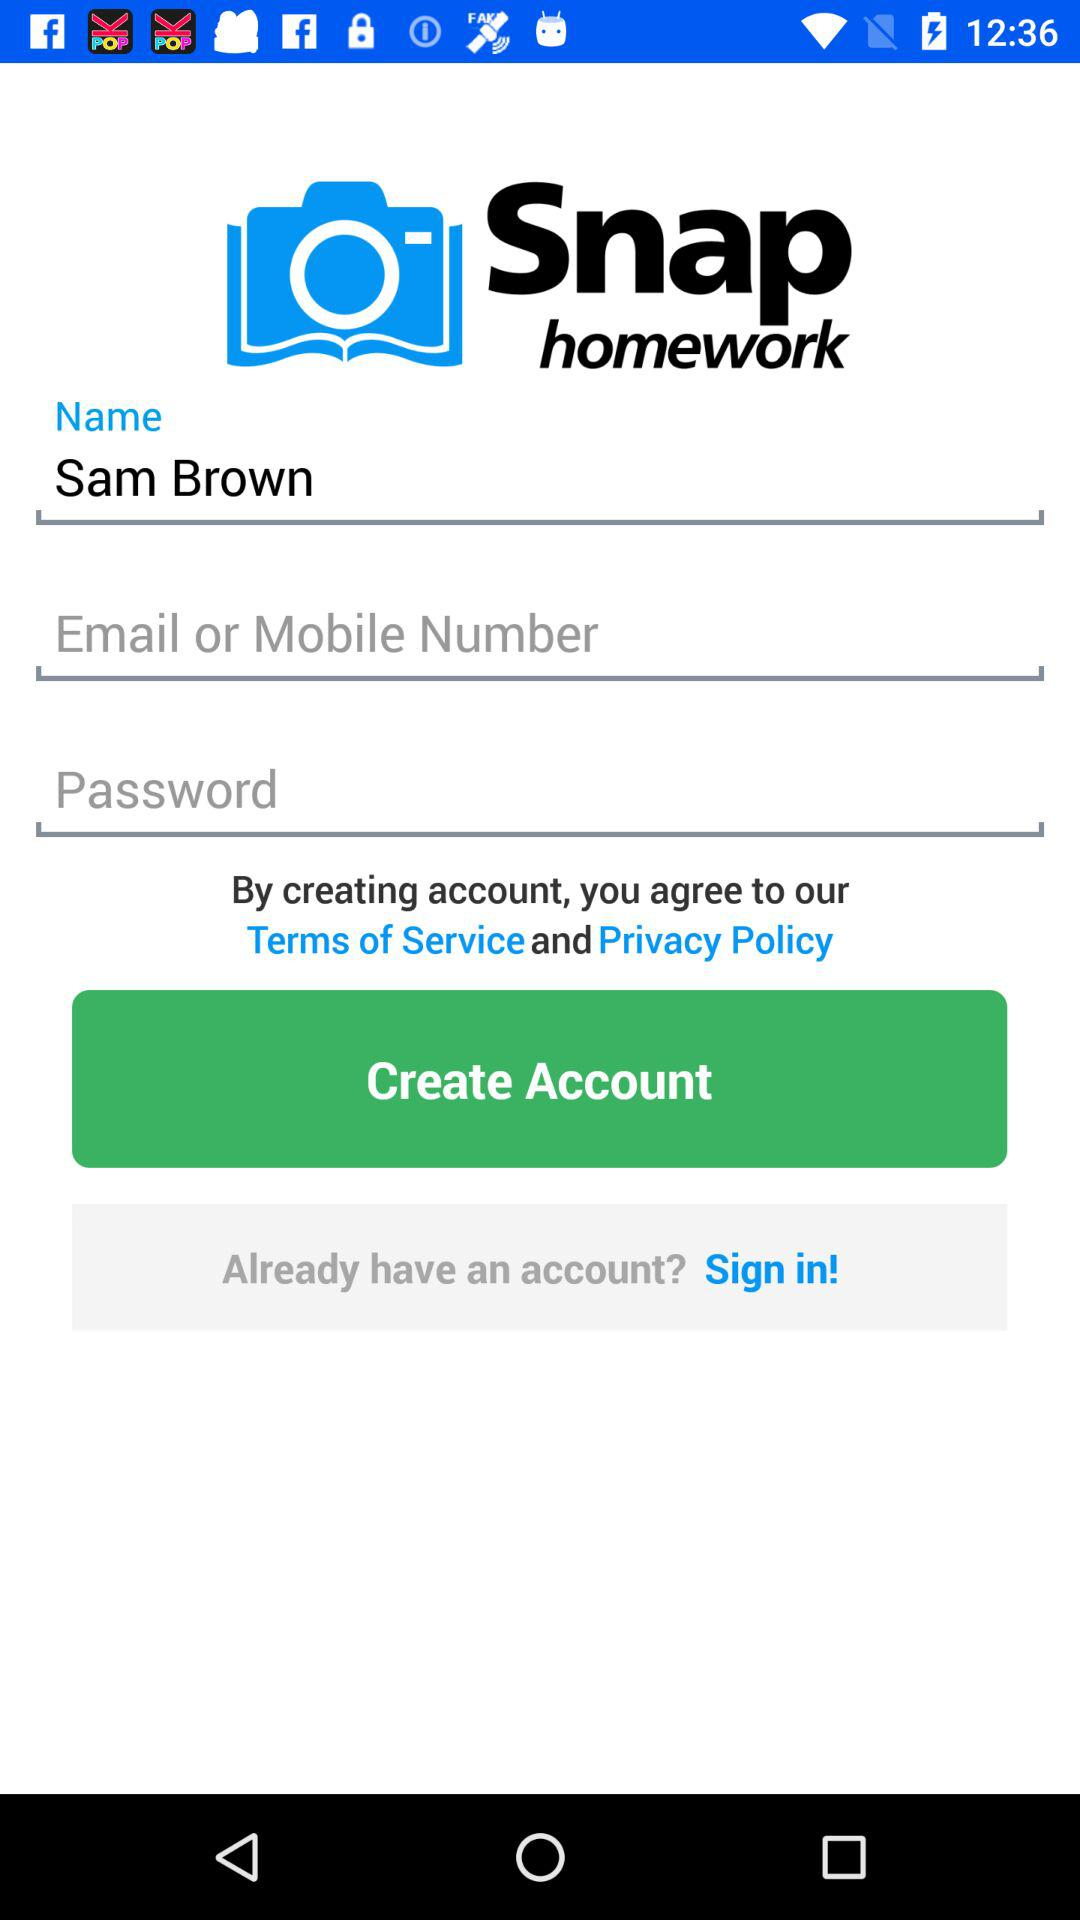What's the user name? The user name is Sam Brown. 